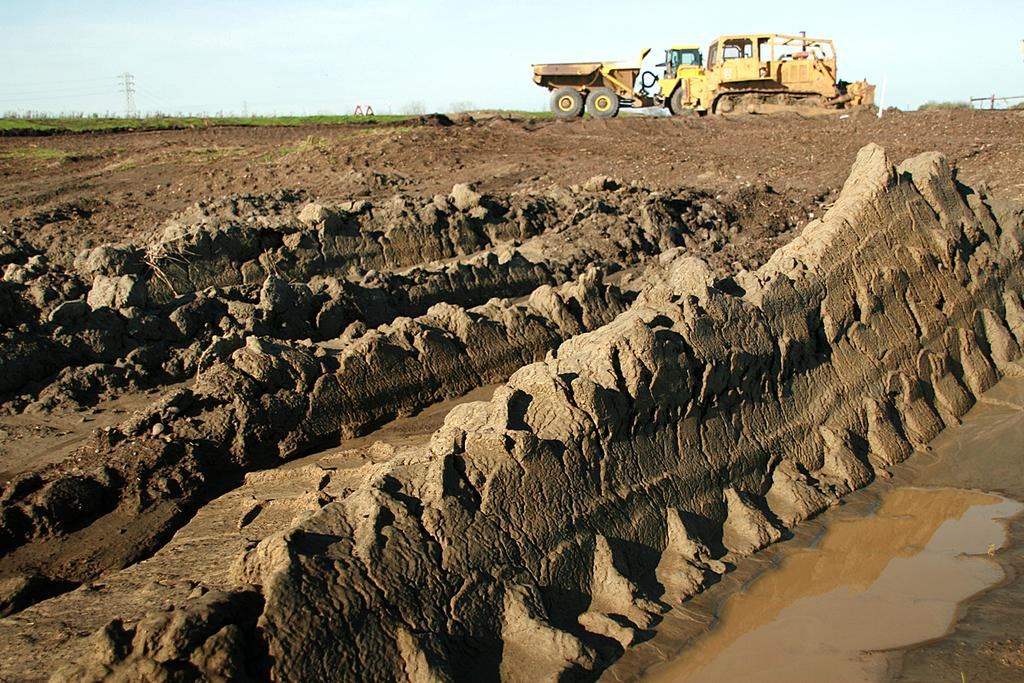What is located in the center of the image? There is water and mud in the center of the image. What can be seen in the background of the image? The sky is visible in the background of the image, along with grass and at least one vehicle. What other objects can be seen in the background of the image? There are a few other objects in the background of the image. What type of crime is being committed in the image? There is no indication of any crime being committed in the image. Is the person in the image sleeping? There is no person visible in the image, so it cannot be determined if anyone is sleeping. 